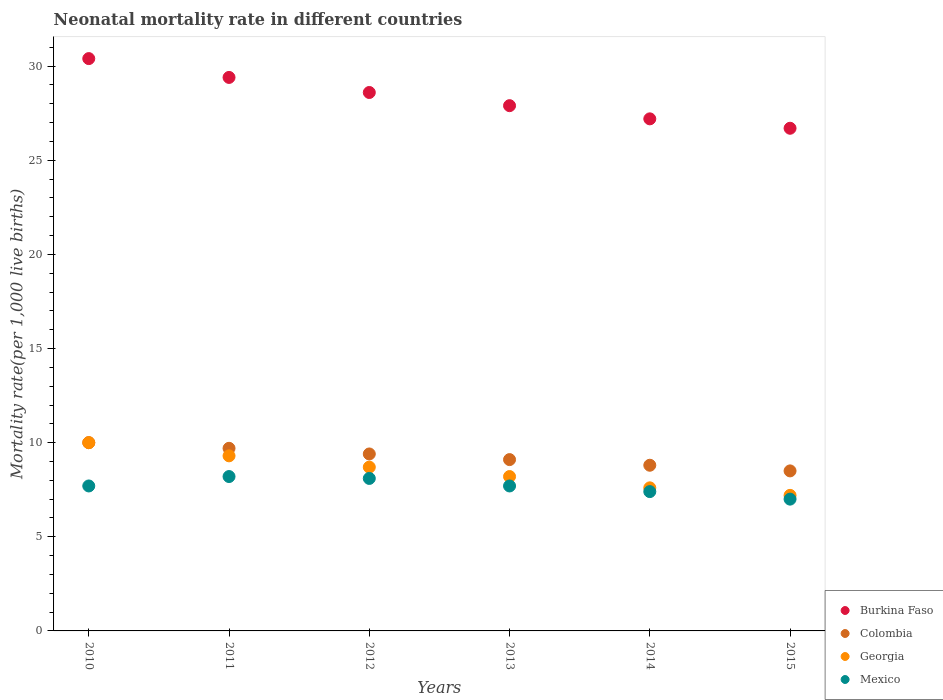How many different coloured dotlines are there?
Your response must be concise. 4. Across all years, what is the maximum neonatal mortality rate in Mexico?
Your response must be concise. 8.2. In which year was the neonatal mortality rate in Georgia maximum?
Your answer should be very brief. 2010. In which year was the neonatal mortality rate in Colombia minimum?
Make the answer very short. 2015. What is the total neonatal mortality rate in Colombia in the graph?
Ensure brevity in your answer.  55.5. What is the difference between the neonatal mortality rate in Mexico in 2013 and that in 2014?
Keep it short and to the point. 0.3. What is the difference between the neonatal mortality rate in Georgia in 2013 and the neonatal mortality rate in Burkina Faso in 2012?
Keep it short and to the point. -20.4. What is the average neonatal mortality rate in Colombia per year?
Ensure brevity in your answer.  9.25. In the year 2010, what is the difference between the neonatal mortality rate in Burkina Faso and neonatal mortality rate in Georgia?
Offer a terse response. 20.4. What is the ratio of the neonatal mortality rate in Georgia in 2010 to that in 2011?
Ensure brevity in your answer.  1.08. What is the difference between the highest and the second highest neonatal mortality rate in Burkina Faso?
Keep it short and to the point. 1. What is the difference between the highest and the lowest neonatal mortality rate in Colombia?
Offer a very short reply. 1.5. In how many years, is the neonatal mortality rate in Georgia greater than the average neonatal mortality rate in Georgia taken over all years?
Make the answer very short. 3. Is the sum of the neonatal mortality rate in Mexico in 2011 and 2015 greater than the maximum neonatal mortality rate in Burkina Faso across all years?
Give a very brief answer. No. Is the neonatal mortality rate in Mexico strictly greater than the neonatal mortality rate in Colombia over the years?
Your response must be concise. No. Is the neonatal mortality rate in Burkina Faso strictly less than the neonatal mortality rate in Mexico over the years?
Keep it short and to the point. No. How many dotlines are there?
Provide a succinct answer. 4. How many years are there in the graph?
Ensure brevity in your answer.  6. Are the values on the major ticks of Y-axis written in scientific E-notation?
Offer a very short reply. No. How many legend labels are there?
Your answer should be compact. 4. How are the legend labels stacked?
Provide a short and direct response. Vertical. What is the title of the graph?
Ensure brevity in your answer.  Neonatal mortality rate in different countries. What is the label or title of the X-axis?
Make the answer very short. Years. What is the label or title of the Y-axis?
Make the answer very short. Mortality rate(per 1,0 live births). What is the Mortality rate(per 1,000 live births) in Burkina Faso in 2010?
Your answer should be very brief. 30.4. What is the Mortality rate(per 1,000 live births) of Colombia in 2010?
Offer a terse response. 10. What is the Mortality rate(per 1,000 live births) of Burkina Faso in 2011?
Make the answer very short. 29.4. What is the Mortality rate(per 1,000 live births) in Georgia in 2011?
Provide a succinct answer. 9.3. What is the Mortality rate(per 1,000 live births) in Burkina Faso in 2012?
Your answer should be very brief. 28.6. What is the Mortality rate(per 1,000 live births) of Colombia in 2012?
Your response must be concise. 9.4. What is the Mortality rate(per 1,000 live births) in Georgia in 2012?
Your answer should be compact. 8.7. What is the Mortality rate(per 1,000 live births) of Mexico in 2012?
Offer a terse response. 8.1. What is the Mortality rate(per 1,000 live births) of Burkina Faso in 2013?
Offer a terse response. 27.9. What is the Mortality rate(per 1,000 live births) of Colombia in 2013?
Keep it short and to the point. 9.1. What is the Mortality rate(per 1,000 live births) of Mexico in 2013?
Provide a succinct answer. 7.7. What is the Mortality rate(per 1,000 live births) of Burkina Faso in 2014?
Give a very brief answer. 27.2. What is the Mortality rate(per 1,000 live births) in Colombia in 2014?
Offer a very short reply. 8.8. What is the Mortality rate(per 1,000 live births) in Georgia in 2014?
Offer a terse response. 7.6. What is the Mortality rate(per 1,000 live births) of Burkina Faso in 2015?
Your answer should be very brief. 26.7. What is the Mortality rate(per 1,000 live births) of Colombia in 2015?
Your answer should be very brief. 8.5. Across all years, what is the maximum Mortality rate(per 1,000 live births) in Burkina Faso?
Your answer should be very brief. 30.4. Across all years, what is the maximum Mortality rate(per 1,000 live births) in Colombia?
Offer a terse response. 10. Across all years, what is the maximum Mortality rate(per 1,000 live births) in Georgia?
Your response must be concise. 10. Across all years, what is the minimum Mortality rate(per 1,000 live births) of Burkina Faso?
Provide a succinct answer. 26.7. Across all years, what is the minimum Mortality rate(per 1,000 live births) in Georgia?
Ensure brevity in your answer.  7.2. Across all years, what is the minimum Mortality rate(per 1,000 live births) of Mexico?
Offer a very short reply. 7. What is the total Mortality rate(per 1,000 live births) in Burkina Faso in the graph?
Give a very brief answer. 170.2. What is the total Mortality rate(per 1,000 live births) of Colombia in the graph?
Give a very brief answer. 55.5. What is the total Mortality rate(per 1,000 live births) in Mexico in the graph?
Your answer should be compact. 46.1. What is the difference between the Mortality rate(per 1,000 live births) in Burkina Faso in 2010 and that in 2011?
Make the answer very short. 1. What is the difference between the Mortality rate(per 1,000 live births) of Colombia in 2010 and that in 2011?
Give a very brief answer. 0.3. What is the difference between the Mortality rate(per 1,000 live births) in Colombia in 2010 and that in 2012?
Your response must be concise. 0.6. What is the difference between the Mortality rate(per 1,000 live births) of Colombia in 2010 and that in 2013?
Your response must be concise. 0.9. What is the difference between the Mortality rate(per 1,000 live births) of Mexico in 2010 and that in 2013?
Provide a succinct answer. 0. What is the difference between the Mortality rate(per 1,000 live births) of Colombia in 2010 and that in 2014?
Provide a succinct answer. 1.2. What is the difference between the Mortality rate(per 1,000 live births) of Colombia in 2011 and that in 2012?
Provide a succinct answer. 0.3. What is the difference between the Mortality rate(per 1,000 live births) in Georgia in 2011 and that in 2012?
Offer a terse response. 0.6. What is the difference between the Mortality rate(per 1,000 live births) in Burkina Faso in 2011 and that in 2013?
Provide a short and direct response. 1.5. What is the difference between the Mortality rate(per 1,000 live births) in Colombia in 2011 and that in 2013?
Give a very brief answer. 0.6. What is the difference between the Mortality rate(per 1,000 live births) of Georgia in 2011 and that in 2013?
Give a very brief answer. 1.1. What is the difference between the Mortality rate(per 1,000 live births) in Mexico in 2011 and that in 2013?
Your response must be concise. 0.5. What is the difference between the Mortality rate(per 1,000 live births) of Burkina Faso in 2011 and that in 2014?
Offer a very short reply. 2.2. What is the difference between the Mortality rate(per 1,000 live births) in Mexico in 2011 and that in 2014?
Your response must be concise. 0.8. What is the difference between the Mortality rate(per 1,000 live births) of Mexico in 2011 and that in 2015?
Provide a short and direct response. 1.2. What is the difference between the Mortality rate(per 1,000 live births) of Burkina Faso in 2012 and that in 2013?
Provide a succinct answer. 0.7. What is the difference between the Mortality rate(per 1,000 live births) of Mexico in 2012 and that in 2013?
Provide a succinct answer. 0.4. What is the difference between the Mortality rate(per 1,000 live births) in Colombia in 2012 and that in 2015?
Give a very brief answer. 0.9. What is the difference between the Mortality rate(per 1,000 live births) of Mexico in 2012 and that in 2015?
Keep it short and to the point. 1.1. What is the difference between the Mortality rate(per 1,000 live births) of Colombia in 2013 and that in 2014?
Ensure brevity in your answer.  0.3. What is the difference between the Mortality rate(per 1,000 live births) in Georgia in 2013 and that in 2014?
Make the answer very short. 0.6. What is the difference between the Mortality rate(per 1,000 live births) of Mexico in 2013 and that in 2014?
Make the answer very short. 0.3. What is the difference between the Mortality rate(per 1,000 live births) of Colombia in 2014 and that in 2015?
Offer a very short reply. 0.3. What is the difference between the Mortality rate(per 1,000 live births) of Georgia in 2014 and that in 2015?
Keep it short and to the point. 0.4. What is the difference between the Mortality rate(per 1,000 live births) of Burkina Faso in 2010 and the Mortality rate(per 1,000 live births) of Colombia in 2011?
Your answer should be compact. 20.7. What is the difference between the Mortality rate(per 1,000 live births) of Burkina Faso in 2010 and the Mortality rate(per 1,000 live births) of Georgia in 2011?
Your answer should be very brief. 21.1. What is the difference between the Mortality rate(per 1,000 live births) in Colombia in 2010 and the Mortality rate(per 1,000 live births) in Georgia in 2011?
Provide a succinct answer. 0.7. What is the difference between the Mortality rate(per 1,000 live births) of Colombia in 2010 and the Mortality rate(per 1,000 live births) of Mexico in 2011?
Keep it short and to the point. 1.8. What is the difference between the Mortality rate(per 1,000 live births) of Georgia in 2010 and the Mortality rate(per 1,000 live births) of Mexico in 2011?
Your answer should be compact. 1.8. What is the difference between the Mortality rate(per 1,000 live births) of Burkina Faso in 2010 and the Mortality rate(per 1,000 live births) of Georgia in 2012?
Make the answer very short. 21.7. What is the difference between the Mortality rate(per 1,000 live births) of Burkina Faso in 2010 and the Mortality rate(per 1,000 live births) of Mexico in 2012?
Offer a very short reply. 22.3. What is the difference between the Mortality rate(per 1,000 live births) in Burkina Faso in 2010 and the Mortality rate(per 1,000 live births) in Colombia in 2013?
Provide a short and direct response. 21.3. What is the difference between the Mortality rate(per 1,000 live births) of Burkina Faso in 2010 and the Mortality rate(per 1,000 live births) of Georgia in 2013?
Keep it short and to the point. 22.2. What is the difference between the Mortality rate(per 1,000 live births) in Burkina Faso in 2010 and the Mortality rate(per 1,000 live births) in Mexico in 2013?
Make the answer very short. 22.7. What is the difference between the Mortality rate(per 1,000 live births) in Colombia in 2010 and the Mortality rate(per 1,000 live births) in Mexico in 2013?
Your response must be concise. 2.3. What is the difference between the Mortality rate(per 1,000 live births) in Burkina Faso in 2010 and the Mortality rate(per 1,000 live births) in Colombia in 2014?
Keep it short and to the point. 21.6. What is the difference between the Mortality rate(per 1,000 live births) in Burkina Faso in 2010 and the Mortality rate(per 1,000 live births) in Georgia in 2014?
Offer a very short reply. 22.8. What is the difference between the Mortality rate(per 1,000 live births) of Burkina Faso in 2010 and the Mortality rate(per 1,000 live births) of Mexico in 2014?
Your answer should be compact. 23. What is the difference between the Mortality rate(per 1,000 live births) in Colombia in 2010 and the Mortality rate(per 1,000 live births) in Georgia in 2014?
Your response must be concise. 2.4. What is the difference between the Mortality rate(per 1,000 live births) in Burkina Faso in 2010 and the Mortality rate(per 1,000 live births) in Colombia in 2015?
Offer a terse response. 21.9. What is the difference between the Mortality rate(per 1,000 live births) in Burkina Faso in 2010 and the Mortality rate(per 1,000 live births) in Georgia in 2015?
Make the answer very short. 23.2. What is the difference between the Mortality rate(per 1,000 live births) in Burkina Faso in 2010 and the Mortality rate(per 1,000 live births) in Mexico in 2015?
Give a very brief answer. 23.4. What is the difference between the Mortality rate(per 1,000 live births) in Colombia in 2010 and the Mortality rate(per 1,000 live births) in Mexico in 2015?
Provide a short and direct response. 3. What is the difference between the Mortality rate(per 1,000 live births) in Georgia in 2010 and the Mortality rate(per 1,000 live births) in Mexico in 2015?
Your answer should be very brief. 3. What is the difference between the Mortality rate(per 1,000 live births) in Burkina Faso in 2011 and the Mortality rate(per 1,000 live births) in Colombia in 2012?
Offer a terse response. 20. What is the difference between the Mortality rate(per 1,000 live births) of Burkina Faso in 2011 and the Mortality rate(per 1,000 live births) of Georgia in 2012?
Ensure brevity in your answer.  20.7. What is the difference between the Mortality rate(per 1,000 live births) in Burkina Faso in 2011 and the Mortality rate(per 1,000 live births) in Mexico in 2012?
Provide a succinct answer. 21.3. What is the difference between the Mortality rate(per 1,000 live births) in Colombia in 2011 and the Mortality rate(per 1,000 live births) in Georgia in 2012?
Make the answer very short. 1. What is the difference between the Mortality rate(per 1,000 live births) of Georgia in 2011 and the Mortality rate(per 1,000 live births) of Mexico in 2012?
Provide a succinct answer. 1.2. What is the difference between the Mortality rate(per 1,000 live births) in Burkina Faso in 2011 and the Mortality rate(per 1,000 live births) in Colombia in 2013?
Provide a short and direct response. 20.3. What is the difference between the Mortality rate(per 1,000 live births) of Burkina Faso in 2011 and the Mortality rate(per 1,000 live births) of Georgia in 2013?
Ensure brevity in your answer.  21.2. What is the difference between the Mortality rate(per 1,000 live births) of Burkina Faso in 2011 and the Mortality rate(per 1,000 live births) of Mexico in 2013?
Keep it short and to the point. 21.7. What is the difference between the Mortality rate(per 1,000 live births) of Colombia in 2011 and the Mortality rate(per 1,000 live births) of Mexico in 2013?
Offer a terse response. 2. What is the difference between the Mortality rate(per 1,000 live births) of Georgia in 2011 and the Mortality rate(per 1,000 live births) of Mexico in 2013?
Provide a short and direct response. 1.6. What is the difference between the Mortality rate(per 1,000 live births) of Burkina Faso in 2011 and the Mortality rate(per 1,000 live births) of Colombia in 2014?
Provide a short and direct response. 20.6. What is the difference between the Mortality rate(per 1,000 live births) of Burkina Faso in 2011 and the Mortality rate(per 1,000 live births) of Georgia in 2014?
Your answer should be very brief. 21.8. What is the difference between the Mortality rate(per 1,000 live births) in Colombia in 2011 and the Mortality rate(per 1,000 live births) in Georgia in 2014?
Give a very brief answer. 2.1. What is the difference between the Mortality rate(per 1,000 live births) of Georgia in 2011 and the Mortality rate(per 1,000 live births) of Mexico in 2014?
Offer a terse response. 1.9. What is the difference between the Mortality rate(per 1,000 live births) in Burkina Faso in 2011 and the Mortality rate(per 1,000 live births) in Colombia in 2015?
Give a very brief answer. 20.9. What is the difference between the Mortality rate(per 1,000 live births) of Burkina Faso in 2011 and the Mortality rate(per 1,000 live births) of Mexico in 2015?
Offer a terse response. 22.4. What is the difference between the Mortality rate(per 1,000 live births) in Colombia in 2011 and the Mortality rate(per 1,000 live births) in Georgia in 2015?
Ensure brevity in your answer.  2.5. What is the difference between the Mortality rate(per 1,000 live births) of Burkina Faso in 2012 and the Mortality rate(per 1,000 live births) of Georgia in 2013?
Give a very brief answer. 20.4. What is the difference between the Mortality rate(per 1,000 live births) in Burkina Faso in 2012 and the Mortality rate(per 1,000 live births) in Mexico in 2013?
Ensure brevity in your answer.  20.9. What is the difference between the Mortality rate(per 1,000 live births) in Colombia in 2012 and the Mortality rate(per 1,000 live births) in Georgia in 2013?
Your answer should be very brief. 1.2. What is the difference between the Mortality rate(per 1,000 live births) of Colombia in 2012 and the Mortality rate(per 1,000 live births) of Mexico in 2013?
Your response must be concise. 1.7. What is the difference between the Mortality rate(per 1,000 live births) in Burkina Faso in 2012 and the Mortality rate(per 1,000 live births) in Colombia in 2014?
Make the answer very short. 19.8. What is the difference between the Mortality rate(per 1,000 live births) of Burkina Faso in 2012 and the Mortality rate(per 1,000 live births) of Georgia in 2014?
Offer a very short reply. 21. What is the difference between the Mortality rate(per 1,000 live births) of Burkina Faso in 2012 and the Mortality rate(per 1,000 live births) of Mexico in 2014?
Give a very brief answer. 21.2. What is the difference between the Mortality rate(per 1,000 live births) of Colombia in 2012 and the Mortality rate(per 1,000 live births) of Mexico in 2014?
Keep it short and to the point. 2. What is the difference between the Mortality rate(per 1,000 live births) in Burkina Faso in 2012 and the Mortality rate(per 1,000 live births) in Colombia in 2015?
Offer a terse response. 20.1. What is the difference between the Mortality rate(per 1,000 live births) in Burkina Faso in 2012 and the Mortality rate(per 1,000 live births) in Georgia in 2015?
Provide a short and direct response. 21.4. What is the difference between the Mortality rate(per 1,000 live births) of Burkina Faso in 2012 and the Mortality rate(per 1,000 live births) of Mexico in 2015?
Offer a very short reply. 21.6. What is the difference between the Mortality rate(per 1,000 live births) in Colombia in 2012 and the Mortality rate(per 1,000 live births) in Georgia in 2015?
Your answer should be compact. 2.2. What is the difference between the Mortality rate(per 1,000 live births) of Burkina Faso in 2013 and the Mortality rate(per 1,000 live births) of Colombia in 2014?
Provide a succinct answer. 19.1. What is the difference between the Mortality rate(per 1,000 live births) of Burkina Faso in 2013 and the Mortality rate(per 1,000 live births) of Georgia in 2014?
Your response must be concise. 20.3. What is the difference between the Mortality rate(per 1,000 live births) in Burkina Faso in 2013 and the Mortality rate(per 1,000 live births) in Georgia in 2015?
Ensure brevity in your answer.  20.7. What is the difference between the Mortality rate(per 1,000 live births) in Burkina Faso in 2013 and the Mortality rate(per 1,000 live births) in Mexico in 2015?
Your answer should be compact. 20.9. What is the difference between the Mortality rate(per 1,000 live births) in Colombia in 2013 and the Mortality rate(per 1,000 live births) in Mexico in 2015?
Provide a short and direct response. 2.1. What is the difference between the Mortality rate(per 1,000 live births) in Burkina Faso in 2014 and the Mortality rate(per 1,000 live births) in Mexico in 2015?
Your answer should be very brief. 20.2. What is the difference between the Mortality rate(per 1,000 live births) in Colombia in 2014 and the Mortality rate(per 1,000 live births) in Georgia in 2015?
Provide a succinct answer. 1.6. What is the difference between the Mortality rate(per 1,000 live births) of Georgia in 2014 and the Mortality rate(per 1,000 live births) of Mexico in 2015?
Give a very brief answer. 0.6. What is the average Mortality rate(per 1,000 live births) in Burkina Faso per year?
Your answer should be compact. 28.37. What is the average Mortality rate(per 1,000 live births) of Colombia per year?
Offer a terse response. 9.25. What is the average Mortality rate(per 1,000 live births) in Georgia per year?
Provide a short and direct response. 8.5. What is the average Mortality rate(per 1,000 live births) of Mexico per year?
Ensure brevity in your answer.  7.68. In the year 2010, what is the difference between the Mortality rate(per 1,000 live births) in Burkina Faso and Mortality rate(per 1,000 live births) in Colombia?
Keep it short and to the point. 20.4. In the year 2010, what is the difference between the Mortality rate(per 1,000 live births) of Burkina Faso and Mortality rate(per 1,000 live births) of Georgia?
Make the answer very short. 20.4. In the year 2010, what is the difference between the Mortality rate(per 1,000 live births) of Burkina Faso and Mortality rate(per 1,000 live births) of Mexico?
Your answer should be very brief. 22.7. In the year 2010, what is the difference between the Mortality rate(per 1,000 live births) in Colombia and Mortality rate(per 1,000 live births) in Mexico?
Your response must be concise. 2.3. In the year 2010, what is the difference between the Mortality rate(per 1,000 live births) of Georgia and Mortality rate(per 1,000 live births) of Mexico?
Offer a terse response. 2.3. In the year 2011, what is the difference between the Mortality rate(per 1,000 live births) in Burkina Faso and Mortality rate(per 1,000 live births) in Colombia?
Provide a succinct answer. 19.7. In the year 2011, what is the difference between the Mortality rate(per 1,000 live births) in Burkina Faso and Mortality rate(per 1,000 live births) in Georgia?
Your answer should be compact. 20.1. In the year 2011, what is the difference between the Mortality rate(per 1,000 live births) of Burkina Faso and Mortality rate(per 1,000 live births) of Mexico?
Provide a short and direct response. 21.2. In the year 2011, what is the difference between the Mortality rate(per 1,000 live births) of Georgia and Mortality rate(per 1,000 live births) of Mexico?
Give a very brief answer. 1.1. In the year 2012, what is the difference between the Mortality rate(per 1,000 live births) of Burkina Faso and Mortality rate(per 1,000 live births) of Colombia?
Provide a succinct answer. 19.2. In the year 2012, what is the difference between the Mortality rate(per 1,000 live births) of Burkina Faso and Mortality rate(per 1,000 live births) of Georgia?
Give a very brief answer. 19.9. In the year 2012, what is the difference between the Mortality rate(per 1,000 live births) in Burkina Faso and Mortality rate(per 1,000 live births) in Mexico?
Ensure brevity in your answer.  20.5. In the year 2012, what is the difference between the Mortality rate(per 1,000 live births) of Colombia and Mortality rate(per 1,000 live births) of Georgia?
Provide a succinct answer. 0.7. In the year 2013, what is the difference between the Mortality rate(per 1,000 live births) of Burkina Faso and Mortality rate(per 1,000 live births) of Colombia?
Your answer should be very brief. 18.8. In the year 2013, what is the difference between the Mortality rate(per 1,000 live births) of Burkina Faso and Mortality rate(per 1,000 live births) of Georgia?
Provide a short and direct response. 19.7. In the year 2013, what is the difference between the Mortality rate(per 1,000 live births) in Burkina Faso and Mortality rate(per 1,000 live births) in Mexico?
Keep it short and to the point. 20.2. In the year 2013, what is the difference between the Mortality rate(per 1,000 live births) of Colombia and Mortality rate(per 1,000 live births) of Georgia?
Make the answer very short. 0.9. In the year 2014, what is the difference between the Mortality rate(per 1,000 live births) in Burkina Faso and Mortality rate(per 1,000 live births) in Georgia?
Your answer should be compact. 19.6. In the year 2014, what is the difference between the Mortality rate(per 1,000 live births) of Burkina Faso and Mortality rate(per 1,000 live births) of Mexico?
Provide a succinct answer. 19.8. In the year 2014, what is the difference between the Mortality rate(per 1,000 live births) in Georgia and Mortality rate(per 1,000 live births) in Mexico?
Keep it short and to the point. 0.2. In the year 2015, what is the difference between the Mortality rate(per 1,000 live births) in Burkina Faso and Mortality rate(per 1,000 live births) in Mexico?
Provide a succinct answer. 19.7. In the year 2015, what is the difference between the Mortality rate(per 1,000 live births) in Colombia and Mortality rate(per 1,000 live births) in Georgia?
Your response must be concise. 1.3. In the year 2015, what is the difference between the Mortality rate(per 1,000 live births) of Colombia and Mortality rate(per 1,000 live births) of Mexico?
Ensure brevity in your answer.  1.5. In the year 2015, what is the difference between the Mortality rate(per 1,000 live births) of Georgia and Mortality rate(per 1,000 live births) of Mexico?
Keep it short and to the point. 0.2. What is the ratio of the Mortality rate(per 1,000 live births) in Burkina Faso in 2010 to that in 2011?
Your response must be concise. 1.03. What is the ratio of the Mortality rate(per 1,000 live births) in Colombia in 2010 to that in 2011?
Make the answer very short. 1.03. What is the ratio of the Mortality rate(per 1,000 live births) in Georgia in 2010 to that in 2011?
Your answer should be compact. 1.08. What is the ratio of the Mortality rate(per 1,000 live births) in Mexico in 2010 to that in 2011?
Offer a terse response. 0.94. What is the ratio of the Mortality rate(per 1,000 live births) in Burkina Faso in 2010 to that in 2012?
Provide a short and direct response. 1.06. What is the ratio of the Mortality rate(per 1,000 live births) in Colombia in 2010 to that in 2012?
Your response must be concise. 1.06. What is the ratio of the Mortality rate(per 1,000 live births) in Georgia in 2010 to that in 2012?
Provide a succinct answer. 1.15. What is the ratio of the Mortality rate(per 1,000 live births) in Mexico in 2010 to that in 2012?
Your response must be concise. 0.95. What is the ratio of the Mortality rate(per 1,000 live births) in Burkina Faso in 2010 to that in 2013?
Your answer should be compact. 1.09. What is the ratio of the Mortality rate(per 1,000 live births) of Colombia in 2010 to that in 2013?
Your response must be concise. 1.1. What is the ratio of the Mortality rate(per 1,000 live births) of Georgia in 2010 to that in 2013?
Give a very brief answer. 1.22. What is the ratio of the Mortality rate(per 1,000 live births) in Burkina Faso in 2010 to that in 2014?
Make the answer very short. 1.12. What is the ratio of the Mortality rate(per 1,000 live births) of Colombia in 2010 to that in 2014?
Give a very brief answer. 1.14. What is the ratio of the Mortality rate(per 1,000 live births) of Georgia in 2010 to that in 2014?
Your response must be concise. 1.32. What is the ratio of the Mortality rate(per 1,000 live births) of Mexico in 2010 to that in 2014?
Ensure brevity in your answer.  1.04. What is the ratio of the Mortality rate(per 1,000 live births) of Burkina Faso in 2010 to that in 2015?
Ensure brevity in your answer.  1.14. What is the ratio of the Mortality rate(per 1,000 live births) in Colombia in 2010 to that in 2015?
Provide a short and direct response. 1.18. What is the ratio of the Mortality rate(per 1,000 live births) of Georgia in 2010 to that in 2015?
Offer a very short reply. 1.39. What is the ratio of the Mortality rate(per 1,000 live births) in Mexico in 2010 to that in 2015?
Your answer should be compact. 1.1. What is the ratio of the Mortality rate(per 1,000 live births) in Burkina Faso in 2011 to that in 2012?
Your answer should be very brief. 1.03. What is the ratio of the Mortality rate(per 1,000 live births) of Colombia in 2011 to that in 2012?
Provide a short and direct response. 1.03. What is the ratio of the Mortality rate(per 1,000 live births) in Georgia in 2011 to that in 2012?
Your answer should be compact. 1.07. What is the ratio of the Mortality rate(per 1,000 live births) in Mexico in 2011 to that in 2012?
Your answer should be very brief. 1.01. What is the ratio of the Mortality rate(per 1,000 live births) of Burkina Faso in 2011 to that in 2013?
Your response must be concise. 1.05. What is the ratio of the Mortality rate(per 1,000 live births) in Colombia in 2011 to that in 2013?
Your response must be concise. 1.07. What is the ratio of the Mortality rate(per 1,000 live births) of Georgia in 2011 to that in 2013?
Your response must be concise. 1.13. What is the ratio of the Mortality rate(per 1,000 live births) in Mexico in 2011 to that in 2013?
Your response must be concise. 1.06. What is the ratio of the Mortality rate(per 1,000 live births) of Burkina Faso in 2011 to that in 2014?
Your response must be concise. 1.08. What is the ratio of the Mortality rate(per 1,000 live births) of Colombia in 2011 to that in 2014?
Ensure brevity in your answer.  1.1. What is the ratio of the Mortality rate(per 1,000 live births) of Georgia in 2011 to that in 2014?
Your response must be concise. 1.22. What is the ratio of the Mortality rate(per 1,000 live births) in Mexico in 2011 to that in 2014?
Offer a very short reply. 1.11. What is the ratio of the Mortality rate(per 1,000 live births) of Burkina Faso in 2011 to that in 2015?
Offer a terse response. 1.1. What is the ratio of the Mortality rate(per 1,000 live births) of Colombia in 2011 to that in 2015?
Ensure brevity in your answer.  1.14. What is the ratio of the Mortality rate(per 1,000 live births) in Georgia in 2011 to that in 2015?
Your answer should be very brief. 1.29. What is the ratio of the Mortality rate(per 1,000 live births) of Mexico in 2011 to that in 2015?
Your answer should be very brief. 1.17. What is the ratio of the Mortality rate(per 1,000 live births) in Burkina Faso in 2012 to that in 2013?
Your answer should be very brief. 1.03. What is the ratio of the Mortality rate(per 1,000 live births) of Colombia in 2012 to that in 2013?
Your response must be concise. 1.03. What is the ratio of the Mortality rate(per 1,000 live births) in Georgia in 2012 to that in 2013?
Offer a terse response. 1.06. What is the ratio of the Mortality rate(per 1,000 live births) in Mexico in 2012 to that in 2013?
Ensure brevity in your answer.  1.05. What is the ratio of the Mortality rate(per 1,000 live births) of Burkina Faso in 2012 to that in 2014?
Keep it short and to the point. 1.05. What is the ratio of the Mortality rate(per 1,000 live births) of Colombia in 2012 to that in 2014?
Ensure brevity in your answer.  1.07. What is the ratio of the Mortality rate(per 1,000 live births) of Georgia in 2012 to that in 2014?
Offer a terse response. 1.14. What is the ratio of the Mortality rate(per 1,000 live births) of Mexico in 2012 to that in 2014?
Your answer should be compact. 1.09. What is the ratio of the Mortality rate(per 1,000 live births) in Burkina Faso in 2012 to that in 2015?
Your answer should be very brief. 1.07. What is the ratio of the Mortality rate(per 1,000 live births) in Colombia in 2012 to that in 2015?
Provide a short and direct response. 1.11. What is the ratio of the Mortality rate(per 1,000 live births) of Georgia in 2012 to that in 2015?
Offer a terse response. 1.21. What is the ratio of the Mortality rate(per 1,000 live births) of Mexico in 2012 to that in 2015?
Your answer should be very brief. 1.16. What is the ratio of the Mortality rate(per 1,000 live births) in Burkina Faso in 2013 to that in 2014?
Your answer should be compact. 1.03. What is the ratio of the Mortality rate(per 1,000 live births) of Colombia in 2013 to that in 2014?
Make the answer very short. 1.03. What is the ratio of the Mortality rate(per 1,000 live births) in Georgia in 2013 to that in 2014?
Give a very brief answer. 1.08. What is the ratio of the Mortality rate(per 1,000 live births) of Mexico in 2013 to that in 2014?
Keep it short and to the point. 1.04. What is the ratio of the Mortality rate(per 1,000 live births) of Burkina Faso in 2013 to that in 2015?
Offer a terse response. 1.04. What is the ratio of the Mortality rate(per 1,000 live births) of Colombia in 2013 to that in 2015?
Offer a very short reply. 1.07. What is the ratio of the Mortality rate(per 1,000 live births) of Georgia in 2013 to that in 2015?
Offer a terse response. 1.14. What is the ratio of the Mortality rate(per 1,000 live births) of Burkina Faso in 2014 to that in 2015?
Your answer should be compact. 1.02. What is the ratio of the Mortality rate(per 1,000 live births) in Colombia in 2014 to that in 2015?
Your answer should be compact. 1.04. What is the ratio of the Mortality rate(per 1,000 live births) in Georgia in 2014 to that in 2015?
Your answer should be very brief. 1.06. What is the ratio of the Mortality rate(per 1,000 live births) in Mexico in 2014 to that in 2015?
Give a very brief answer. 1.06. What is the difference between the highest and the second highest Mortality rate(per 1,000 live births) of Georgia?
Offer a very short reply. 0.7. What is the difference between the highest and the second highest Mortality rate(per 1,000 live births) in Mexico?
Your answer should be very brief. 0.1. 